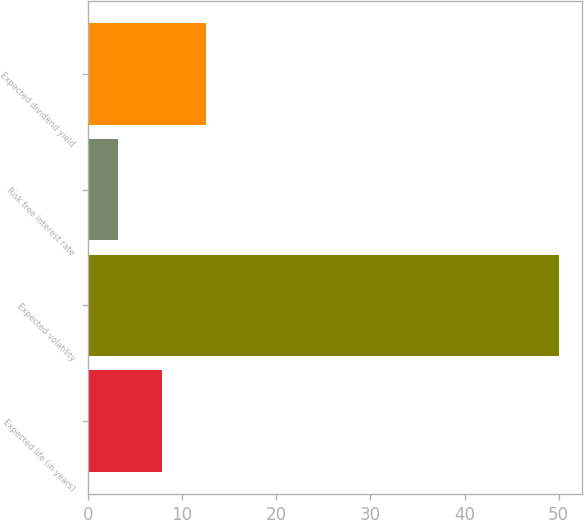Convert chart to OTSL. <chart><loc_0><loc_0><loc_500><loc_500><bar_chart><fcel>Expected life (in years)<fcel>Expected volatility<fcel>Risk free interest rate<fcel>Expected dividend yield<nl><fcel>7.88<fcel>50<fcel>3.2<fcel>12.56<nl></chart> 